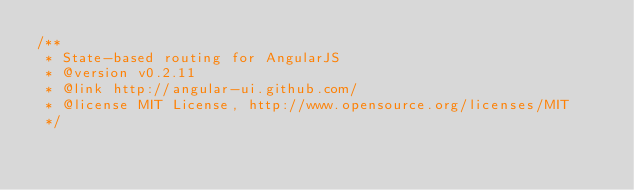Convert code to text. <code><loc_0><loc_0><loc_500><loc_500><_JavaScript_>/**
 * State-based routing for AngularJS
 * @version v0.2.11
 * @link http://angular-ui.github.com/
 * @license MIT License, http://www.opensource.org/licenses/MIT
 */</code> 